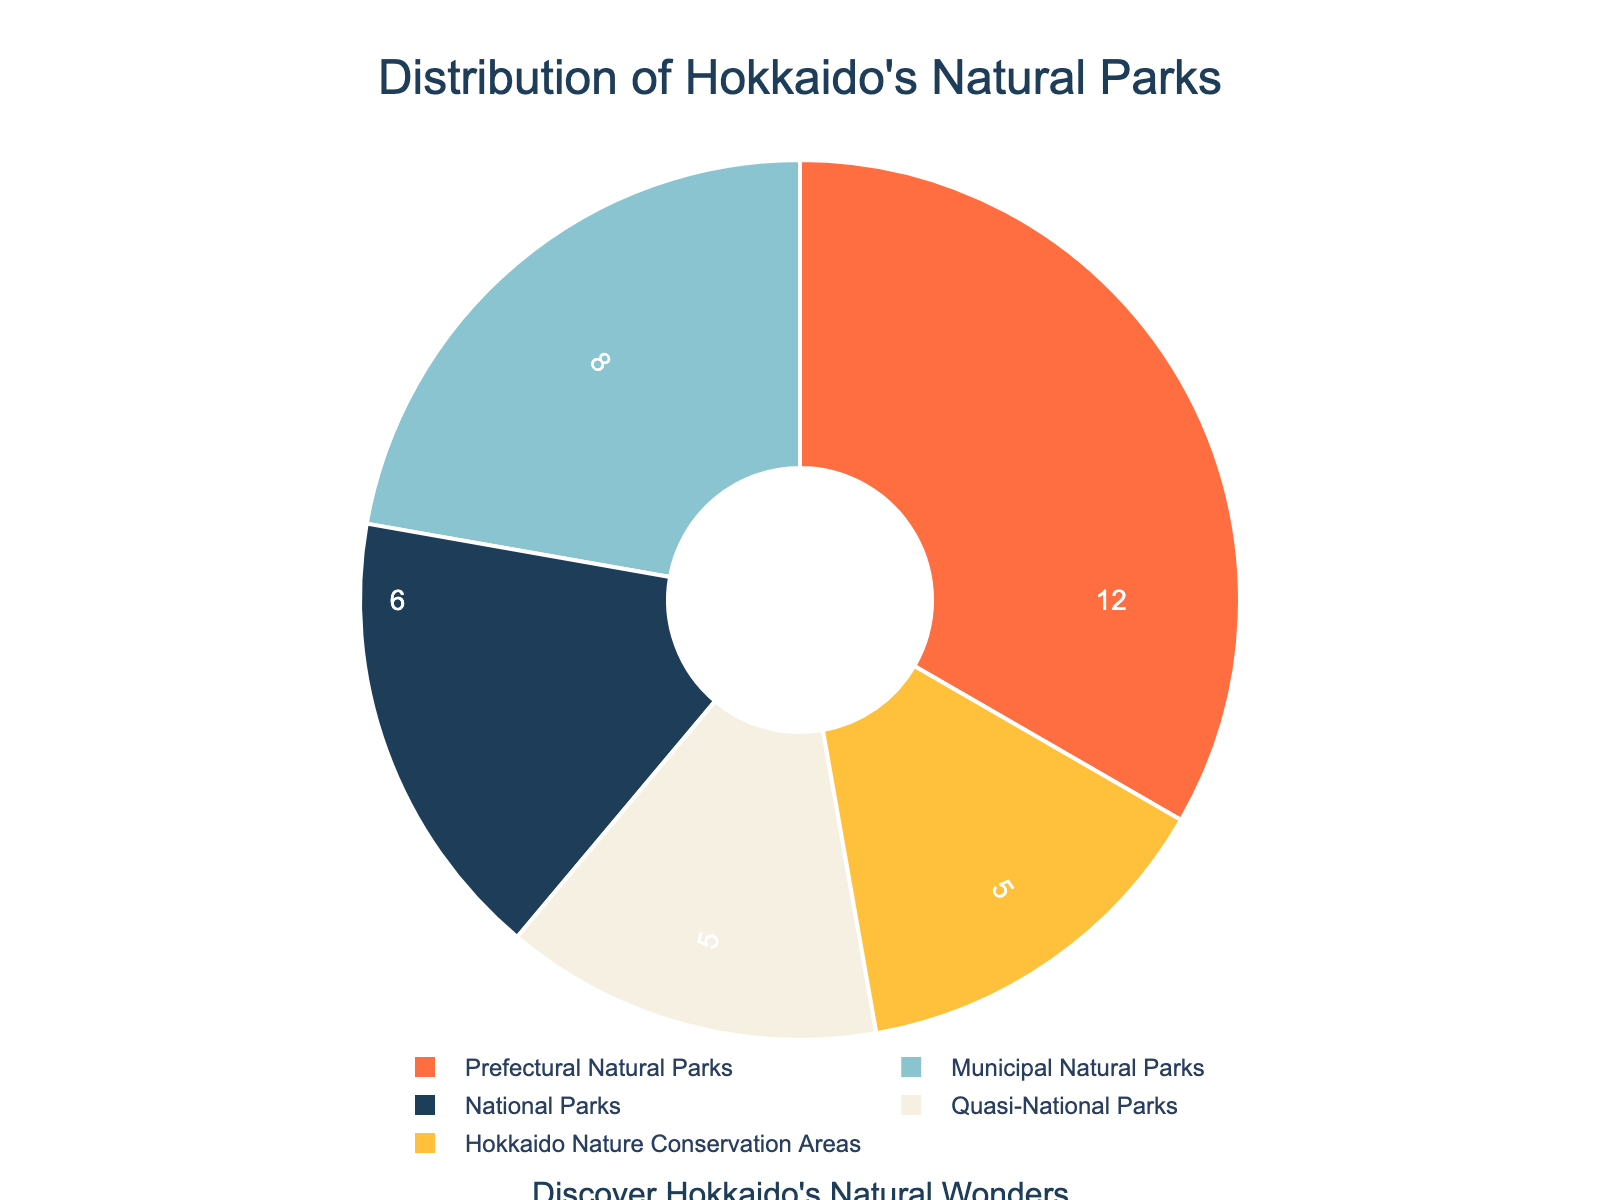What is the most common type of natural park in Hokkaido? From the pie chart, Prefectural Natural Parks have the largest slice, indicating they are the most common type.
Answer: Prefectural Natural Parks What percentage of natural parks are National Parks? By observing the label and percentage associated with the National Parks slice, you can see the percentage.
Answer: 22% How many more Prefectural Natural Parks are there compared to Quasi-National Parks? Prefectural Natural Parks are 12, and Quasi-National Parks are 5, so the difference is 12 - 5 = 7.
Answer: 7 Which type of natural park has the smallest presence in Hokkaido? By comparing the sizes of the slices, the smallest one is either Quasi-National Parks or Hokkaido Nature Conservation Areas. Both have the same number.
Answer: Quasi-National Parks / Hokkaido Nature Conservation Areas What is the total number of natural parks represented in the pie chart? Sum the values given for all the types of parks: 6 + 5 + 12 + 5 + 8 = 36.
Answer: 36 What is the average number of parks per category? Sum the number of parks and divide by the number of categories: (6 + 5 + 12 + 5 + 8) / 5 = 36 / 5 = 7.2.
Answer: 7.2 Are there more Municipal Natural Parks or National Parks? By observing the numbers represented on the pie chart, Municipal Natural Parks are 8 while National Parks are 6.
Answer: Municipal Natural Parks What fraction of the natural parks are Hokkaido Nature Conservation Areas? The number of Hokkaido Nature Conservation Areas is 5. The total number of parks is 36. The fraction is 5/36.
Answer: 5/36 Which slice color represents Quasi-National Parks? Visual inspection of the pie chart shows the color associated with Quasi-National Parks.
Answer: Light grey/off-white Is the percentage of Municipal Natural Parks more than 20%? Observe the percentage label associated with the Municipal Natural Parks slice to answer yes or no.
Answer: Yes 